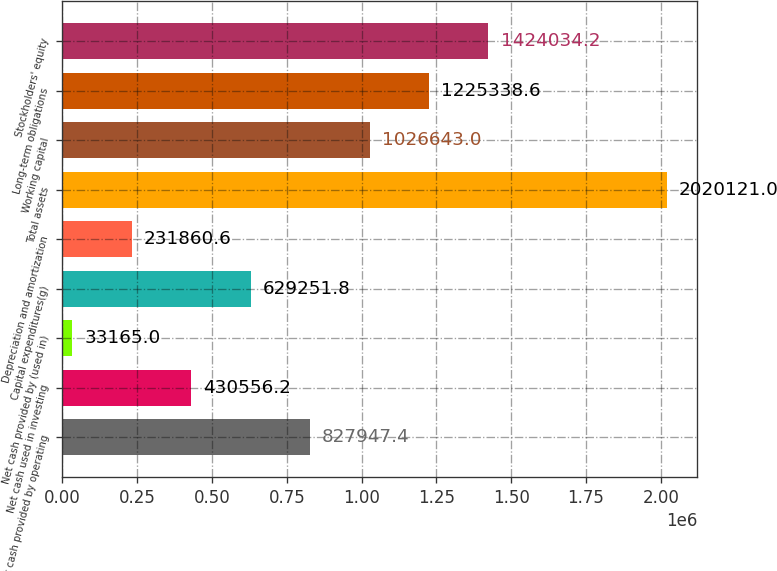<chart> <loc_0><loc_0><loc_500><loc_500><bar_chart><fcel>Net cash provided by operating<fcel>Net cash used in investing<fcel>Net cash provided by (used in)<fcel>Capital expenditures(g)<fcel>Depreciation and amortization<fcel>Total assets<fcel>Working capital<fcel>Long-term obligations<fcel>Stockholders' equity<nl><fcel>827947<fcel>430556<fcel>33165<fcel>629252<fcel>231861<fcel>2.02012e+06<fcel>1.02664e+06<fcel>1.22534e+06<fcel>1.42403e+06<nl></chart> 